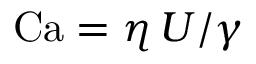Convert formula to latex. <formula><loc_0><loc_0><loc_500><loc_500>C a = \eta \, U / \gamma</formula> 